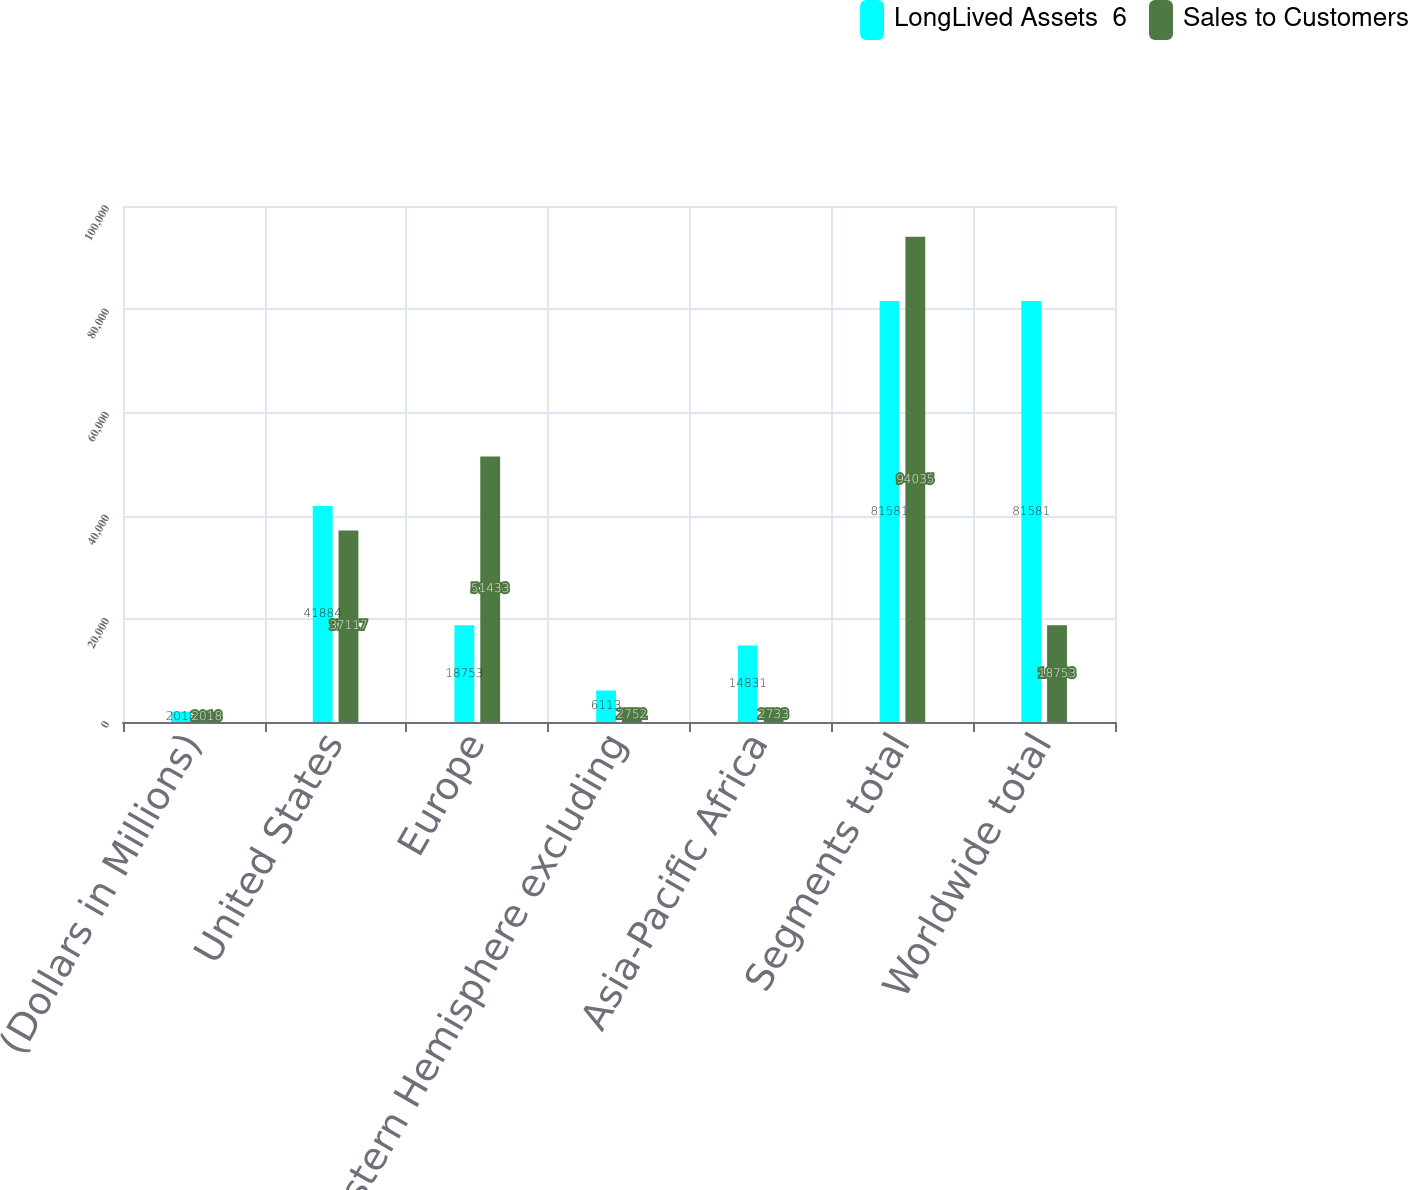Convert chart to OTSL. <chart><loc_0><loc_0><loc_500><loc_500><stacked_bar_chart><ecel><fcel>(Dollars in Millions)<fcel>United States<fcel>Europe<fcel>Western Hemisphere excluding<fcel>Asia-Pacific Africa<fcel>Segments total<fcel>Worldwide total<nl><fcel>LongLived Assets  6<fcel>2018<fcel>41884<fcel>18753<fcel>6113<fcel>14831<fcel>81581<fcel>81581<nl><fcel>Sales to Customers<fcel>2018<fcel>37117<fcel>51433<fcel>2752<fcel>2733<fcel>94035<fcel>18753<nl></chart> 